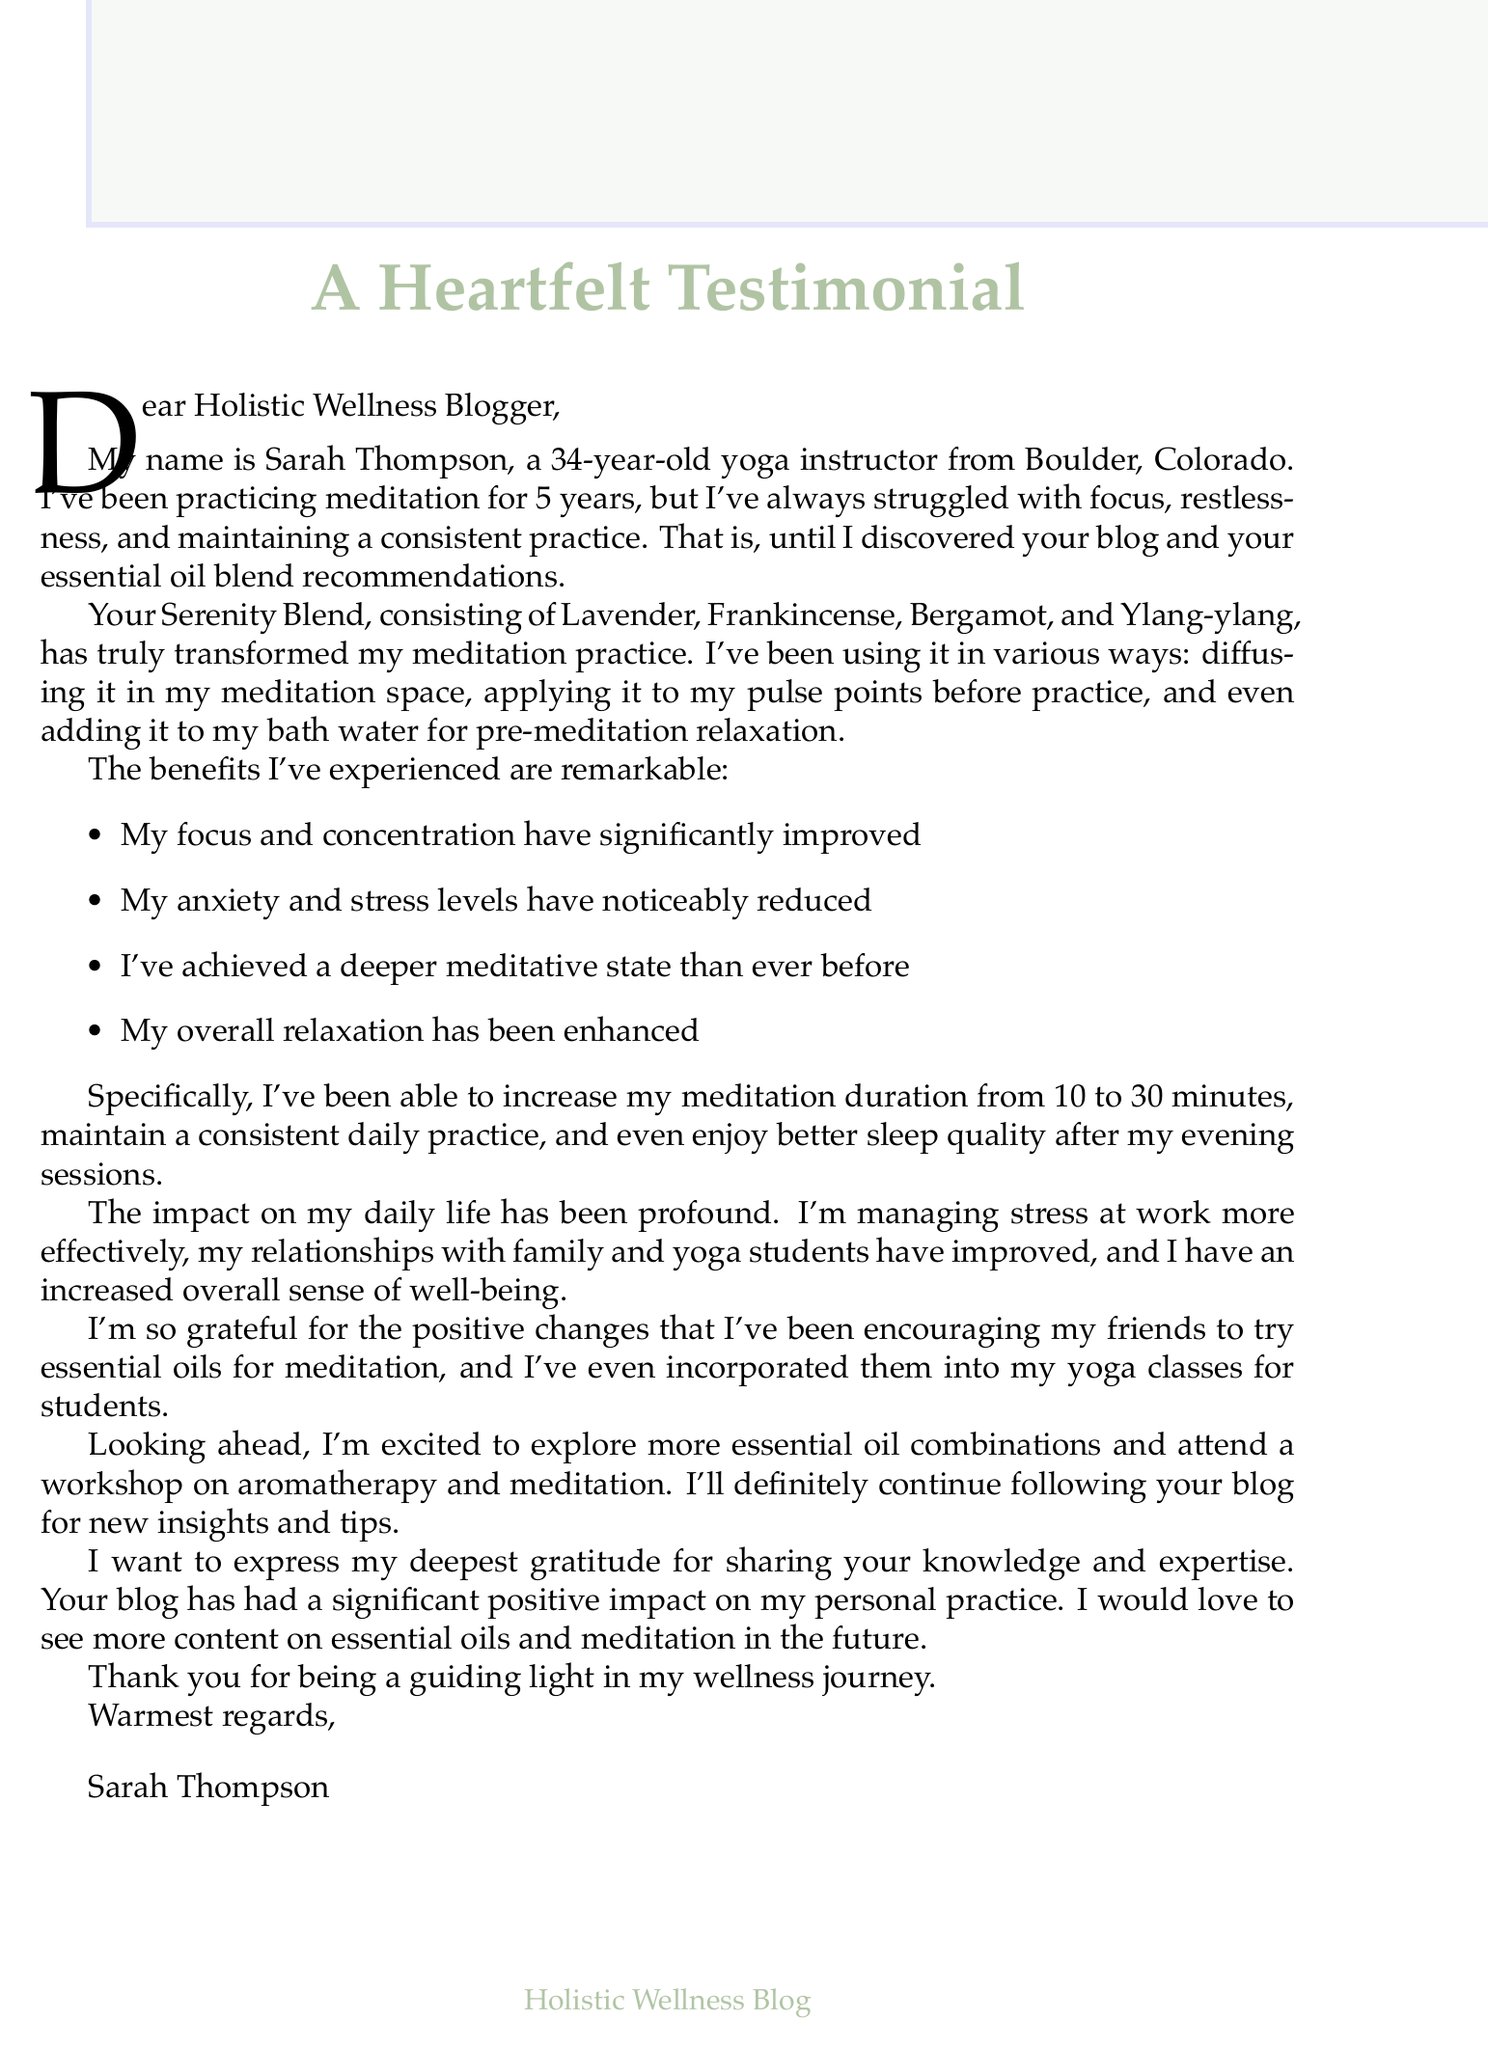What is the name of the reader? The name of the reader is explicitly mentioned at the beginning of the letter.
Answer: Sarah Thompson How old is Sarah? Sarah's age is stated in the introductory section of the letter.
Answer: 34 What essential oil blend did Sarah use? The letter specifies the name of the blend that Sarah used for her meditation practice.
Answer: Serenity Blend What improvement occurred in Sarah's meditation duration? The letter details how Sarah's meditation duration increased from one amount to another.
Answer: Increased from 10 to 30 minutes What emotions did Sarah express regarding the changes? The letter lists the feelings Sarah experienced due to the changes from using the essential oils.
Answer: Gratitude for the positive changes What benefit did Sarah experience related to sleep? The letter includes specific improvements Sarah noted after her meditation sessions.
Answer: Better sleep quality after evening meditation sessions How did Sarah use the essential oil blend before meditating? The letter provides information on multiple ways Sarah incorporated the blend into her practice.
Answer: Applied to pulse points before practice What has Sarah encouraged her friends to do? The letter mentions a specific action Sarah took regarding her friends and essential oils.
Answer: Try essential oils for meditation What future plans does Sarah mention? The letter contains a section detailing Sarah's intentions for further exploration and learning.
Answer: Explore more essential oil combinations 